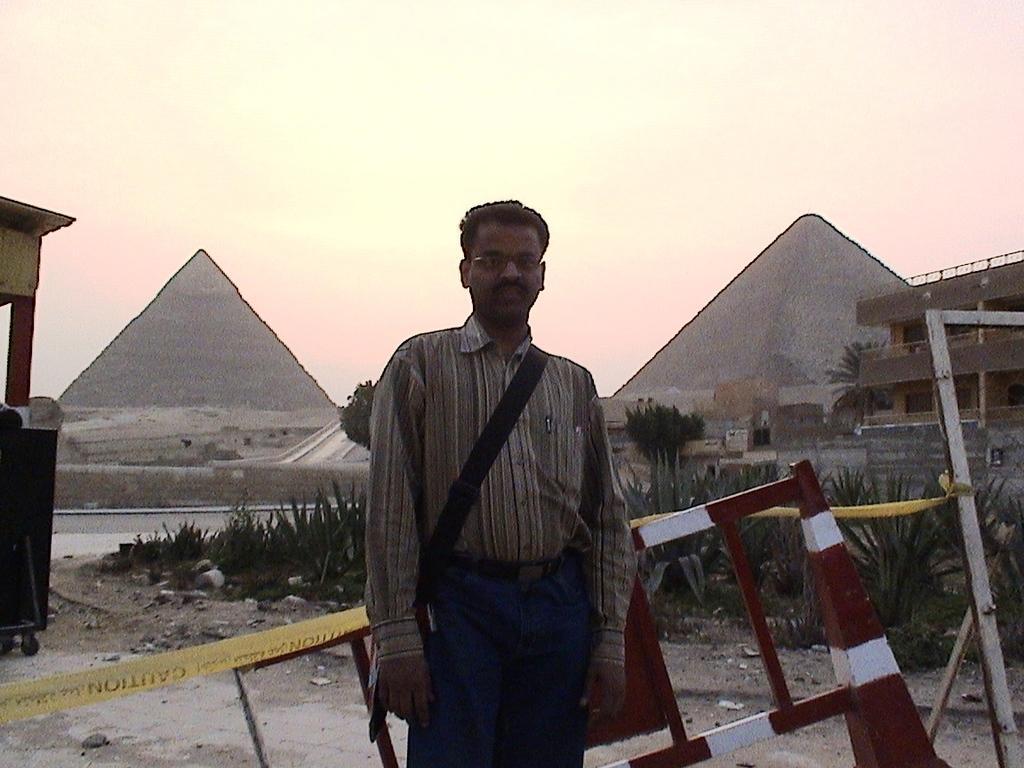Describe this image in one or two sentences. In the middle of the image we can see a man, he wore a bag, behind him we can see few metal rods, plants, trees and buildings, and also we can see pyramids. 